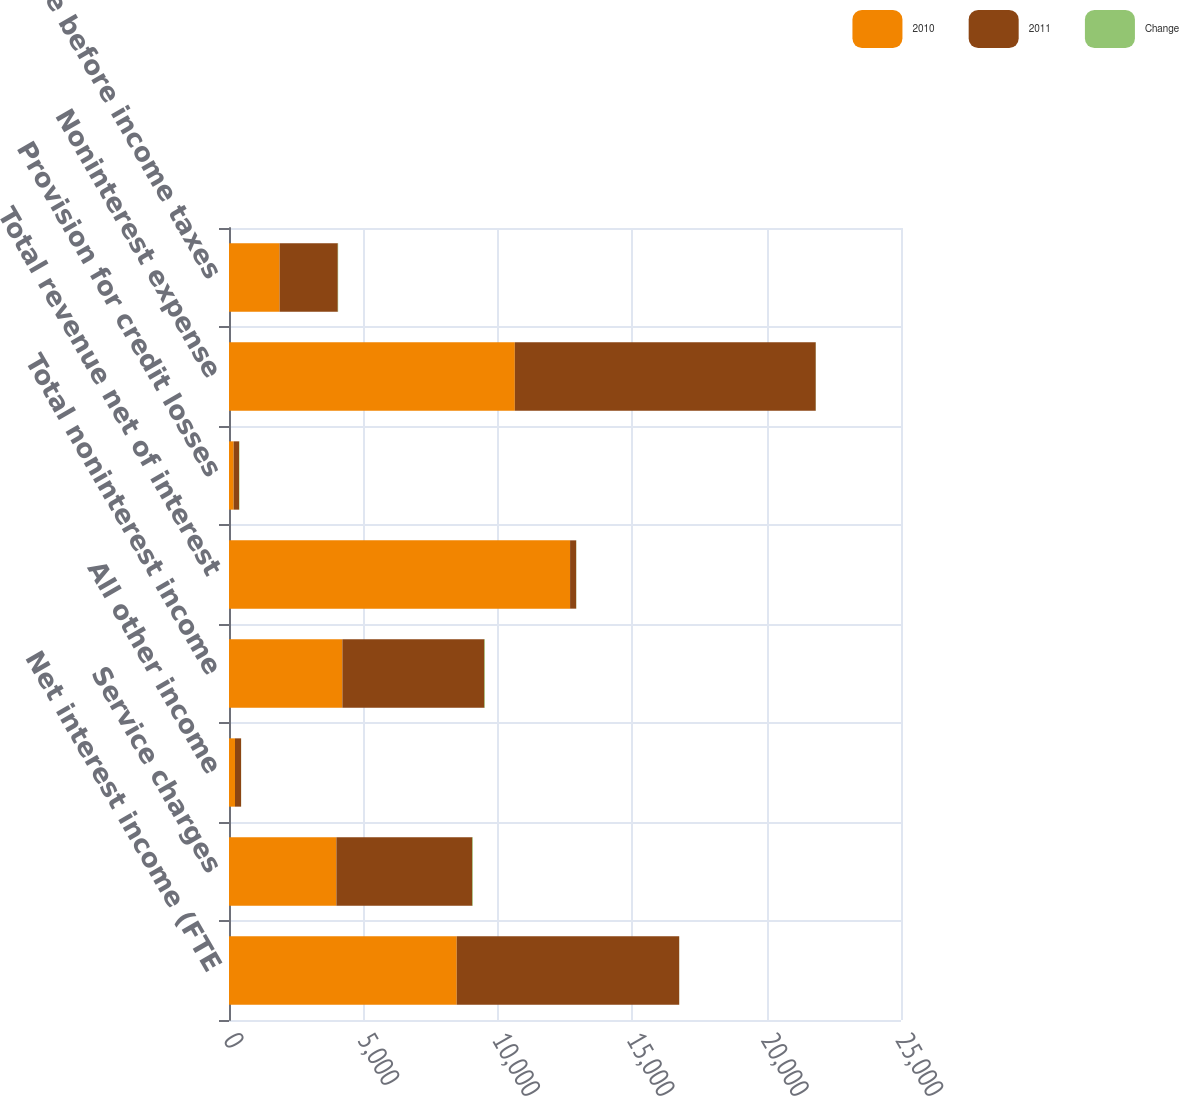Convert chart. <chart><loc_0><loc_0><loc_500><loc_500><stacked_bar_chart><ecel><fcel>Net interest income (FTE<fcel>Service charges<fcel>All other income<fcel>Total noninterest income<fcel>Total revenue net of interest<fcel>Provision for credit losses<fcel>Noninterest expense<fcel>Income before income taxes<nl><fcel>2010<fcel>8471<fcel>3995<fcel>223<fcel>4218<fcel>12689<fcel>173<fcel>10633<fcel>1883<nl><fcel>2011<fcel>8278<fcel>5057<fcel>227<fcel>5284<fcel>227<fcel>201<fcel>11196<fcel>2165<nl><fcel>Change<fcel>2<fcel>21<fcel>2<fcel>20<fcel>6<fcel>14<fcel>5<fcel>13<nl></chart> 